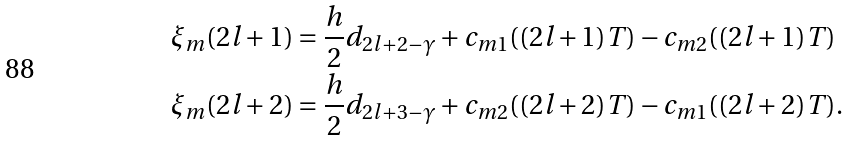Convert formula to latex. <formula><loc_0><loc_0><loc_500><loc_500>\xi _ { m } ( 2 l + 1 ) & = \frac { h } { 2 } d _ { 2 l + 2 - \gamma } + c _ { m 1 } ( ( 2 l + 1 ) T ) - c _ { m 2 } ( ( 2 l + 1 ) T ) \\ \xi _ { m } ( 2 l + 2 ) & = \frac { h } { 2 } d _ { 2 l + 3 - \gamma } + c _ { m 2 } ( ( 2 l + 2 ) T ) - c _ { m 1 } ( ( 2 l + 2 ) T ) \text {.}</formula> 